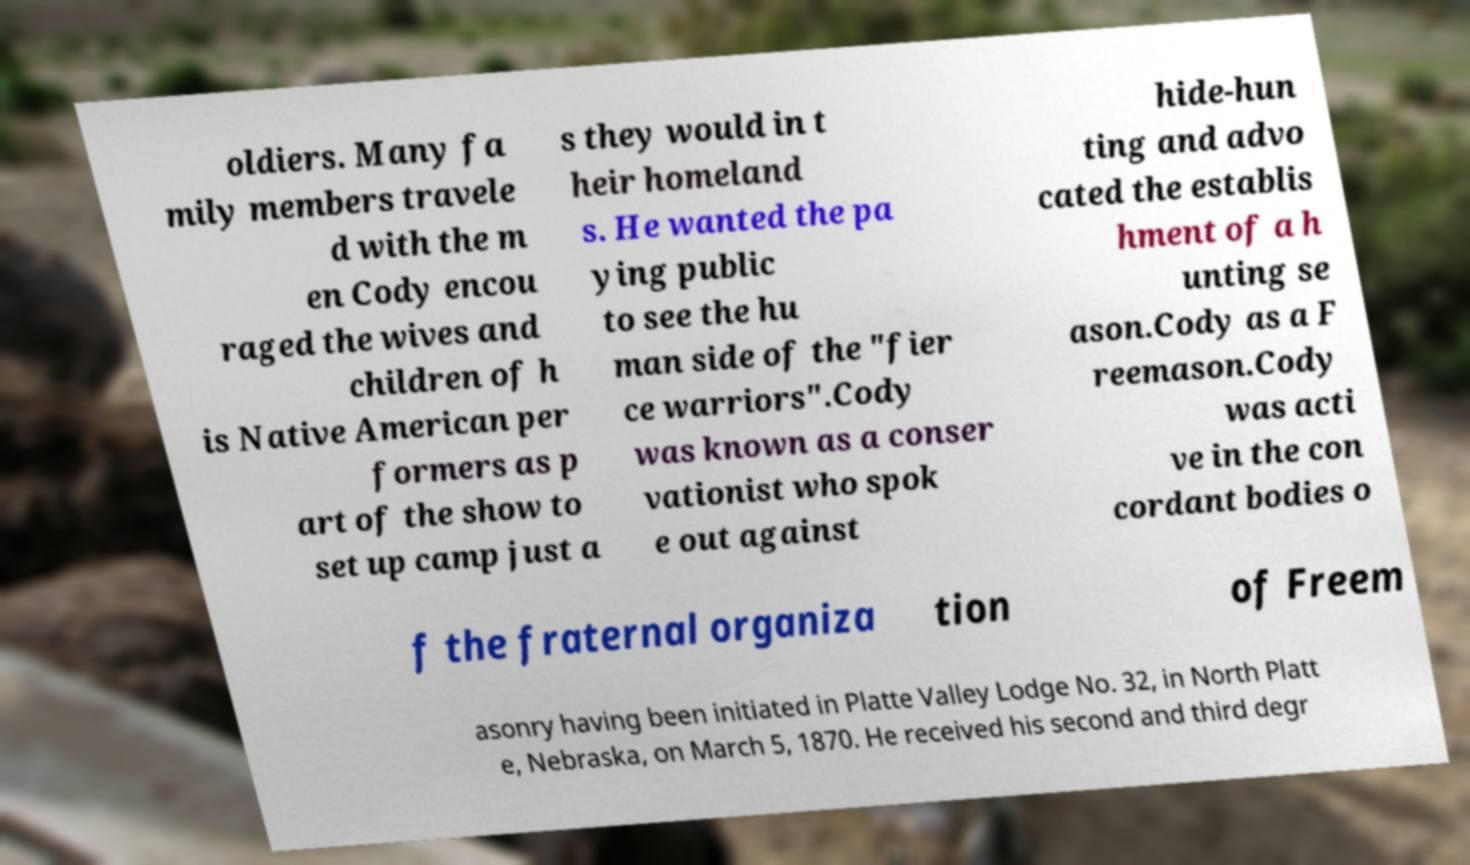Please identify and transcribe the text found in this image. oldiers. Many fa mily members travele d with the m en Cody encou raged the wives and children of h is Native American per formers as p art of the show to set up camp just a s they would in t heir homeland s. He wanted the pa ying public to see the hu man side of the "fier ce warriors".Cody was known as a conser vationist who spok e out against hide-hun ting and advo cated the establis hment of a h unting se ason.Cody as a F reemason.Cody was acti ve in the con cordant bodies o f the fraternal organiza tion of Freem asonry having been initiated in Platte Valley Lodge No. 32, in North Platt e, Nebraska, on March 5, 1870. He received his second and third degr 